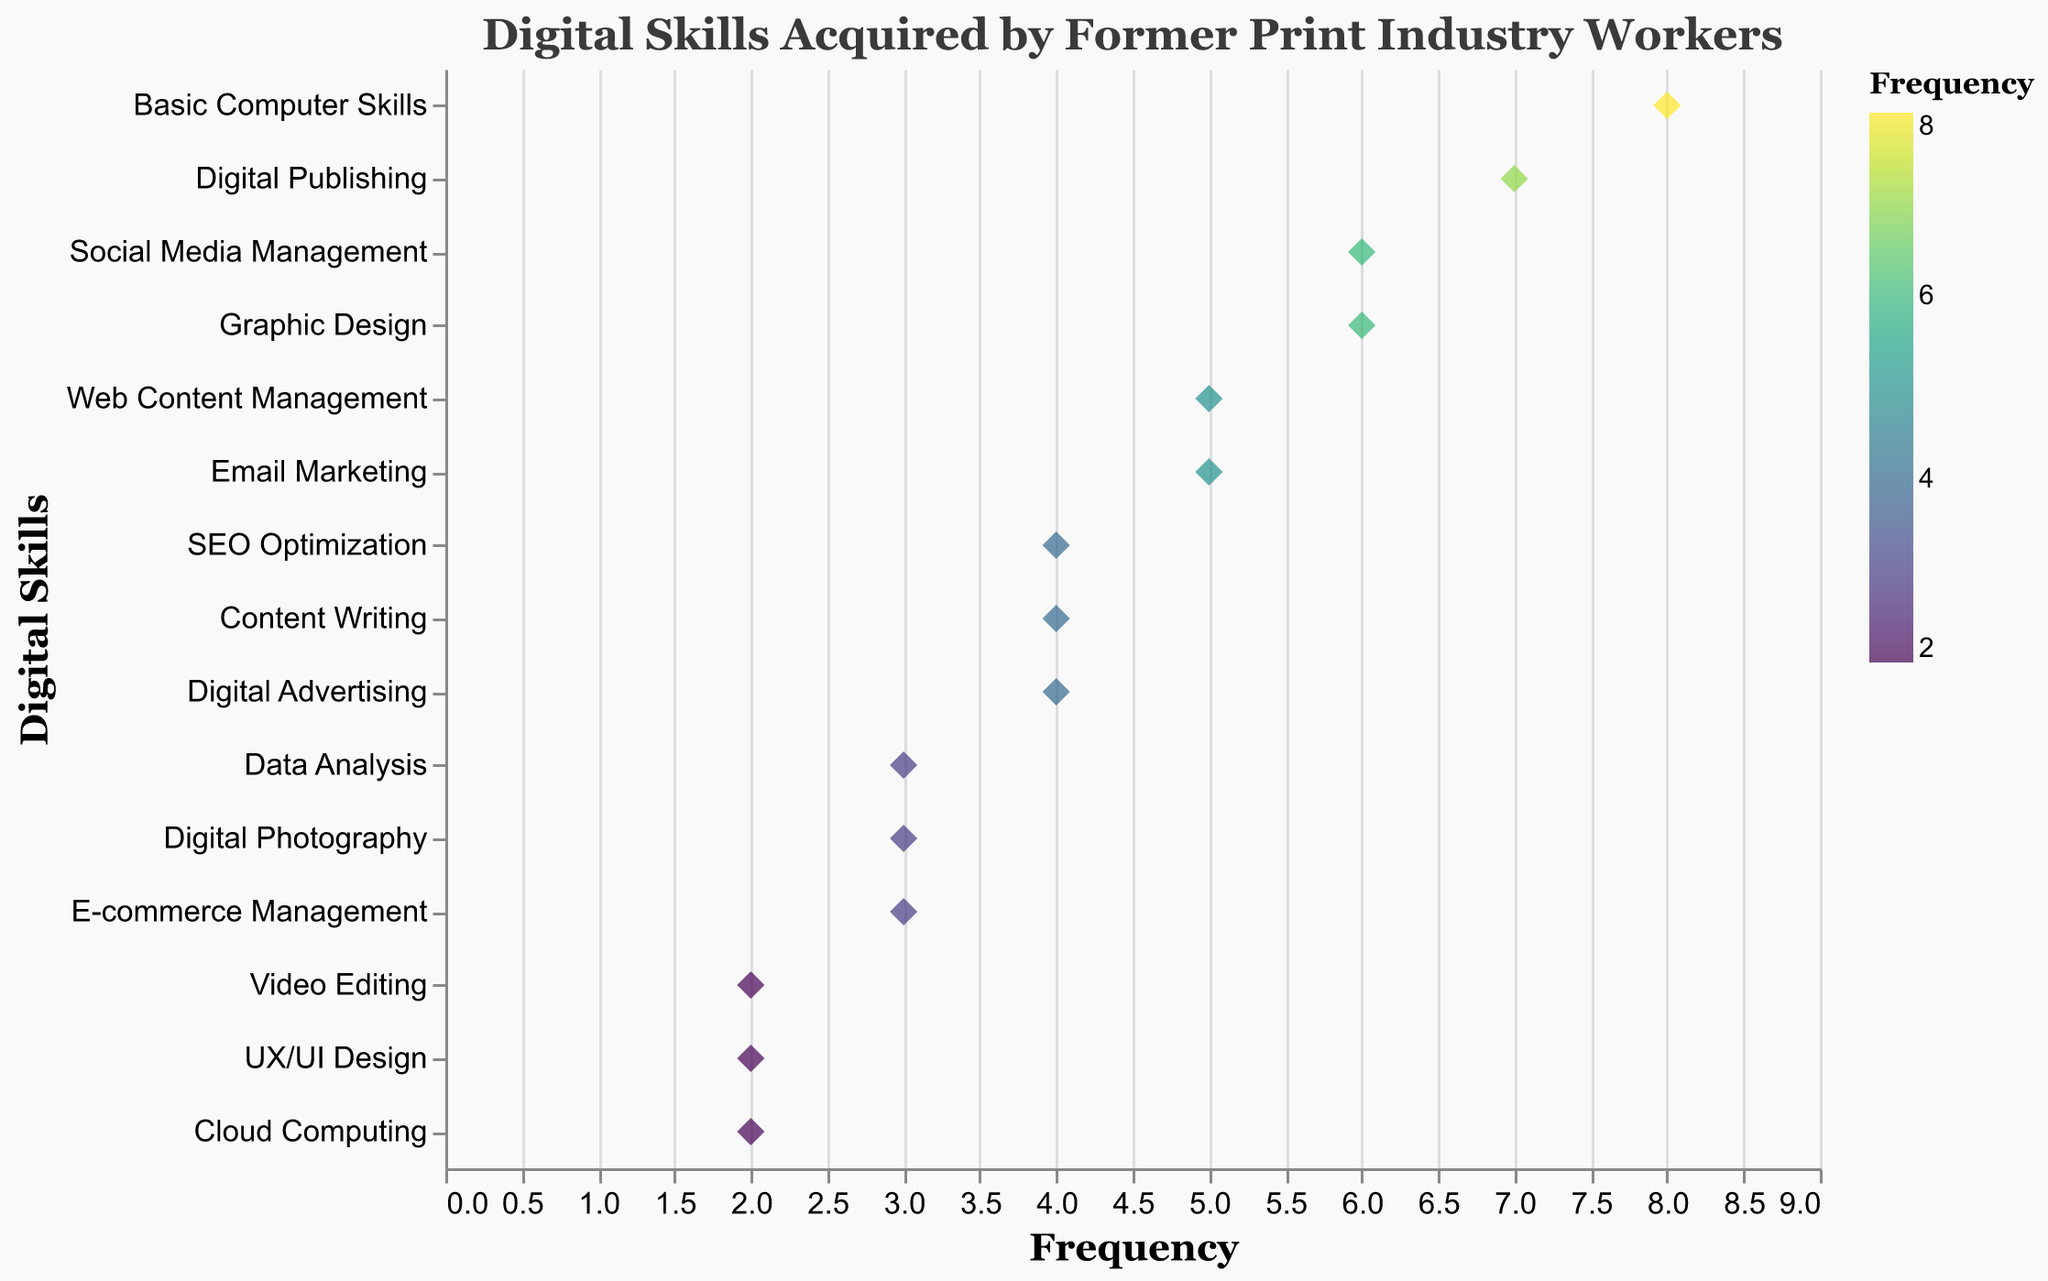What's the title of the figure? The title of the figure is the text displayed at the top of the plot. It provides an overview of what the figure is about.
Answer: "Digital Skills Acquired by Former Print Industry Workers" What is the skill with the highest frequency? The skill with the highest frequency is the one that has the point farthest to the right on the x-axis.
Answer: Basic Computer Skills Which skills have a frequency of 6? To find this, look for points that are at the position 6 on the x-axis and identify the corresponding skills listed on the y-axis.
Answer: Social Media Management, Graphic Design How many skills have a frequency of 2? Count the number of points that are positioned at 2 on the x-axis.
Answer: 3 What is the average frequency of the skills listed? Add up all the frequency values and divide by the number of skills. That is (8+6+7+5+4+5+3+6+2+4+3+2+3+4+2)/15.
Answer: 4.2 Which skill has the lowest frequency? The skill with the lowest frequency has the point farthest to the left on the x-axis.
Answer: Video Editing, UX/UI Design, Cloud Computing Is there any skill that has both its frequency and color at the maximum level? The frequency's maximum value is 8, and according to the color scheme, maximum frequency corresponds to the darkest color shade. Check for these conditions.
Answer: Yes, Basic Computer Skills What’s the total frequency for skills related to content creation (Content Writing and Digital Publishing)? Sum the frequencies of Content Writing and Digital Publishing. 4 + 7 = 11.
Answer: 11 How does the frequency of Data Analysis compare to Basic Computer Skills? Compare the x-axis position of Data Analysis and Basic Computer Skills.
Answer: Data Analysis is less frequent than Basic Computer Skills Which two skills share the same frequency and are located next to each other on the y-axis? Locate skills that have identical x-axis values and are adjacent in the y-axis order.
Answer: Content Writing and Digital Advertising 